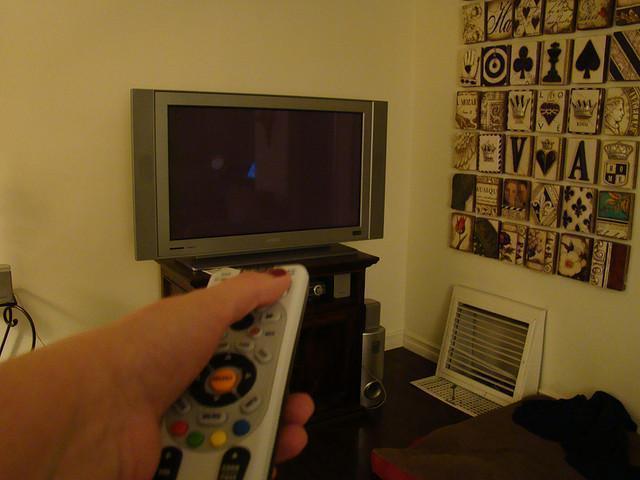What does this person want to do?
From the following set of four choices, select the accurate answer to respond to the question.
Options: Pay cashier, make dinner, change channel, take shower. Change channel. 